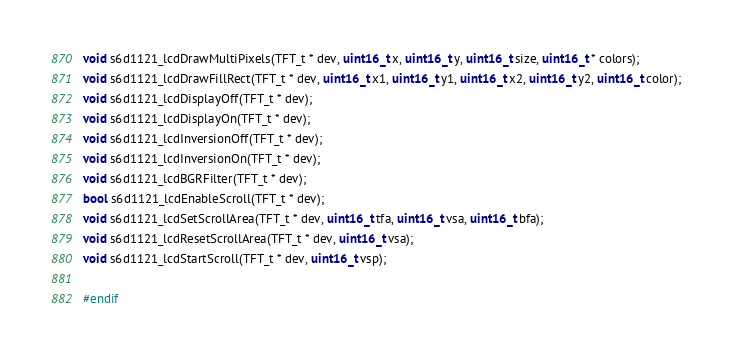<code> <loc_0><loc_0><loc_500><loc_500><_C_>void s6d1121_lcdDrawMultiPixels(TFT_t * dev, uint16_t x, uint16_t y, uint16_t size, uint16_t * colors);
void s6d1121_lcdDrawFillRect(TFT_t * dev, uint16_t x1, uint16_t y1, uint16_t x2, uint16_t y2, uint16_t color);
void s6d1121_lcdDisplayOff(TFT_t * dev);
void s6d1121_lcdDisplayOn(TFT_t * dev);
void s6d1121_lcdInversionOff(TFT_t * dev);
void s6d1121_lcdInversionOn(TFT_t * dev);
void s6d1121_lcdBGRFilter(TFT_t * dev);
bool s6d1121_lcdEnableScroll(TFT_t * dev);
void s6d1121_lcdSetScrollArea(TFT_t * dev, uint16_t tfa, uint16_t vsa, uint16_t bfa);
void s6d1121_lcdResetScrollArea(TFT_t * dev, uint16_t vsa);
void s6d1121_lcdStartScroll(TFT_t * dev, uint16_t vsp);

#endif

</code> 